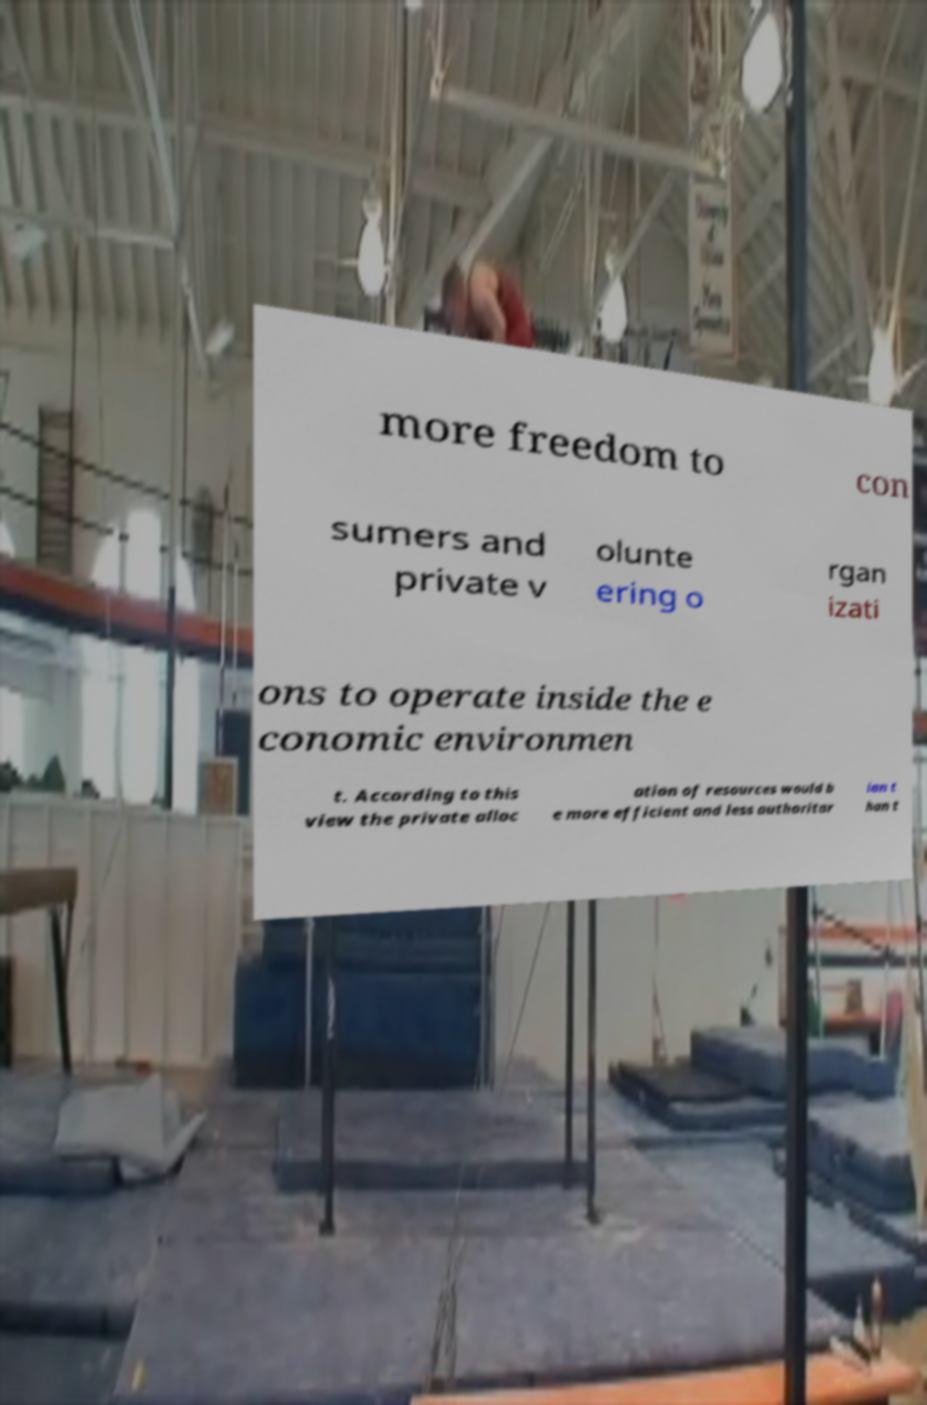I need the written content from this picture converted into text. Can you do that? more freedom to con sumers and private v olunte ering o rgan izati ons to operate inside the e conomic environmen t. According to this view the private alloc ation of resources would b e more efficient and less authoritar ian t han t 